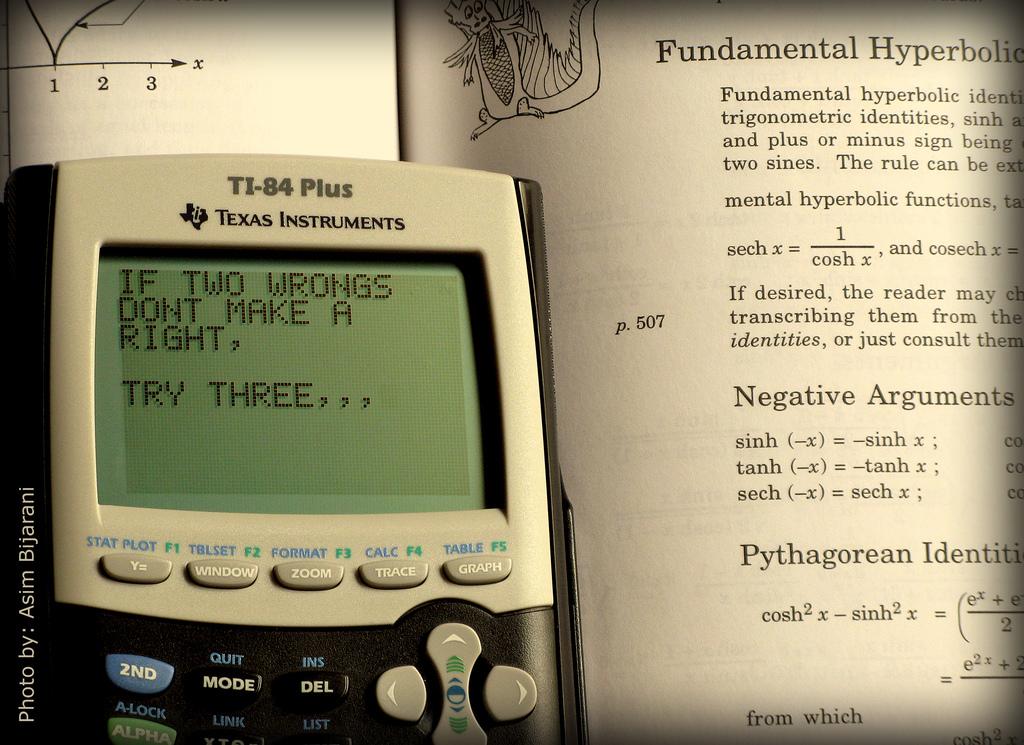What subject is this person studying?
Your answer should be compact. Fundamental hyperbolic. What is the brand name?
Your answer should be compact. Texas instruments. 